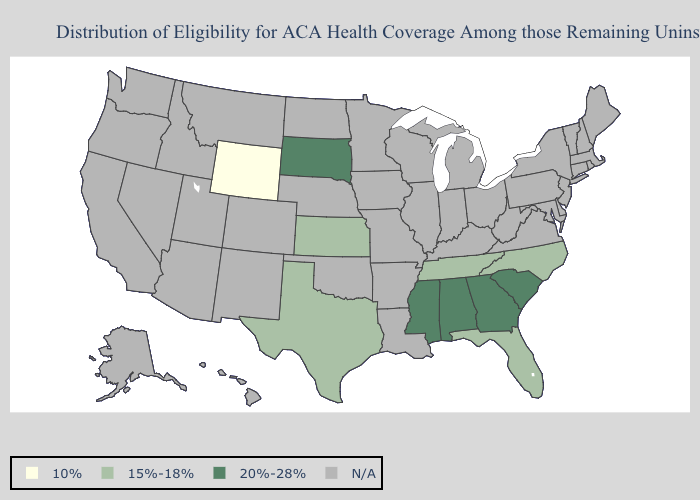What is the value of Colorado?
Be succinct. N/A. What is the value of Wyoming?
Keep it brief. 10%. Does South Dakota have the lowest value in the MidWest?
Answer briefly. No. Name the states that have a value in the range 10%?
Keep it brief. Wyoming. What is the value of Nebraska?
Quick response, please. N/A. What is the value of Washington?
Answer briefly. N/A. What is the value of Hawaii?
Be succinct. N/A. What is the value of Alabama?
Quick response, please. 20%-28%. Name the states that have a value in the range 15%-18%?
Quick response, please. Florida, Kansas, North Carolina, Tennessee, Texas. Name the states that have a value in the range N/A?
Quick response, please. Alaska, Arizona, Arkansas, California, Colorado, Connecticut, Delaware, Hawaii, Idaho, Illinois, Indiana, Iowa, Kentucky, Louisiana, Maine, Maryland, Massachusetts, Michigan, Minnesota, Missouri, Montana, Nebraska, Nevada, New Hampshire, New Jersey, New Mexico, New York, North Dakota, Ohio, Oklahoma, Oregon, Pennsylvania, Rhode Island, Utah, Vermont, Virginia, Washington, West Virginia, Wisconsin. 